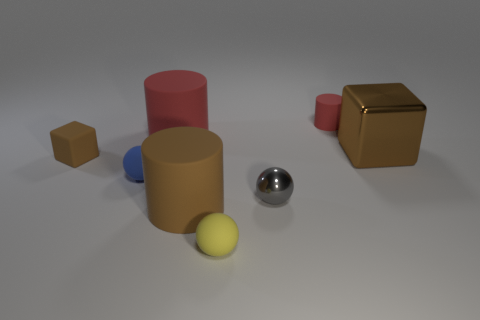Subtract all red cylinders. How many were subtracted if there are1red cylinders left? 1 Add 2 brown cubes. How many objects exist? 10 Subtract all cubes. How many objects are left? 6 Add 4 cyan matte blocks. How many cyan matte blocks exist? 4 Subtract 0 gray blocks. How many objects are left? 8 Subtract all small yellow balls. Subtract all yellow objects. How many objects are left? 6 Add 8 small yellow rubber things. How many small yellow rubber things are left? 9 